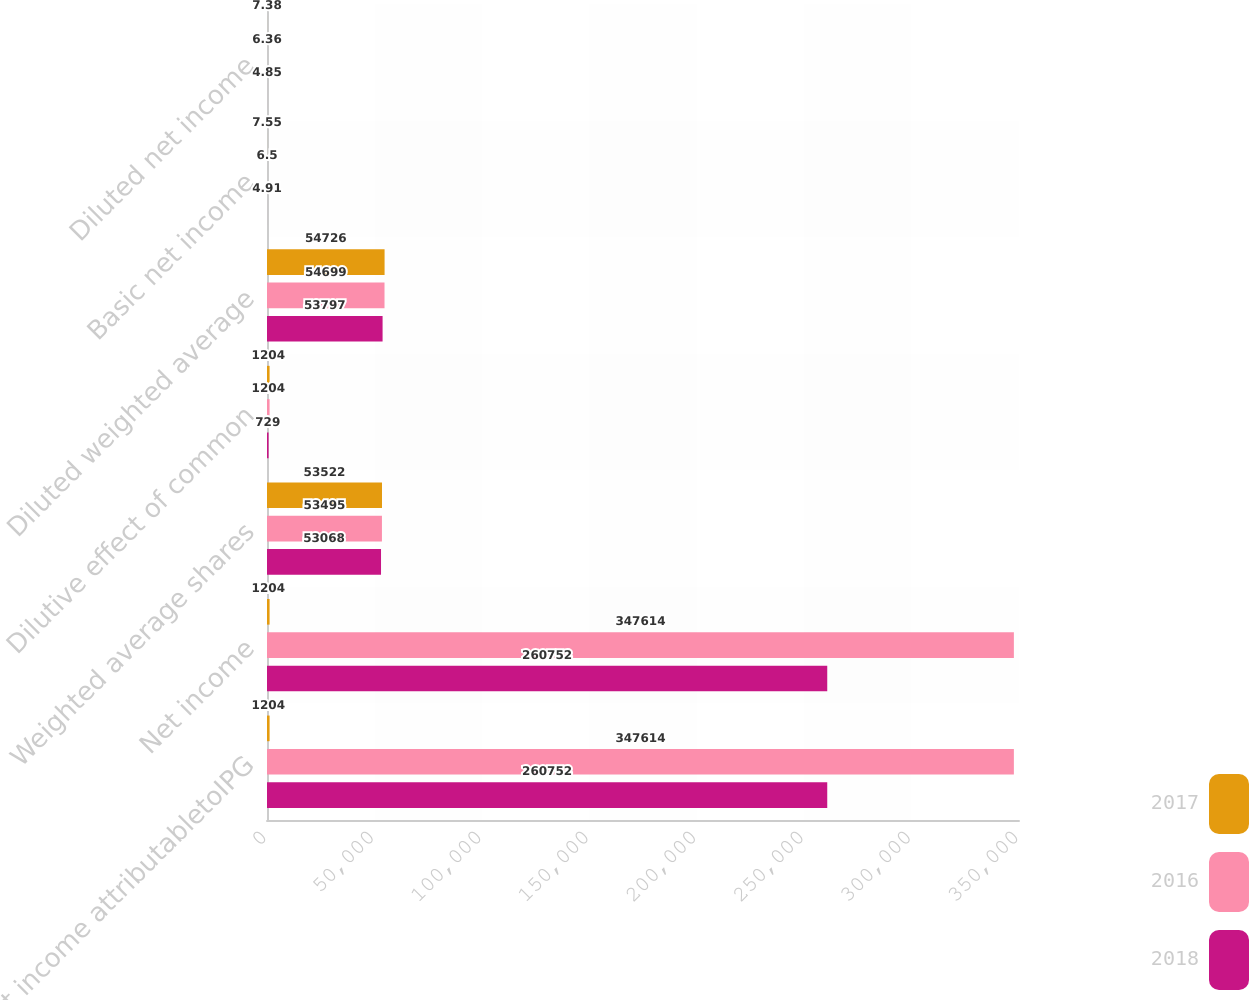Convert chart. <chart><loc_0><loc_0><loc_500><loc_500><stacked_bar_chart><ecel><fcel>Net income attributabletoIPG<fcel>Net income<fcel>Weighted average shares<fcel>Dilutive effect of common<fcel>Diluted weighted average<fcel>Basic net income<fcel>Diluted net income<nl><fcel>2017<fcel>1204<fcel>1204<fcel>53522<fcel>1204<fcel>54726<fcel>7.55<fcel>7.38<nl><fcel>2016<fcel>347614<fcel>347614<fcel>53495<fcel>1204<fcel>54699<fcel>6.5<fcel>6.36<nl><fcel>2018<fcel>260752<fcel>260752<fcel>53068<fcel>729<fcel>53797<fcel>4.91<fcel>4.85<nl></chart> 